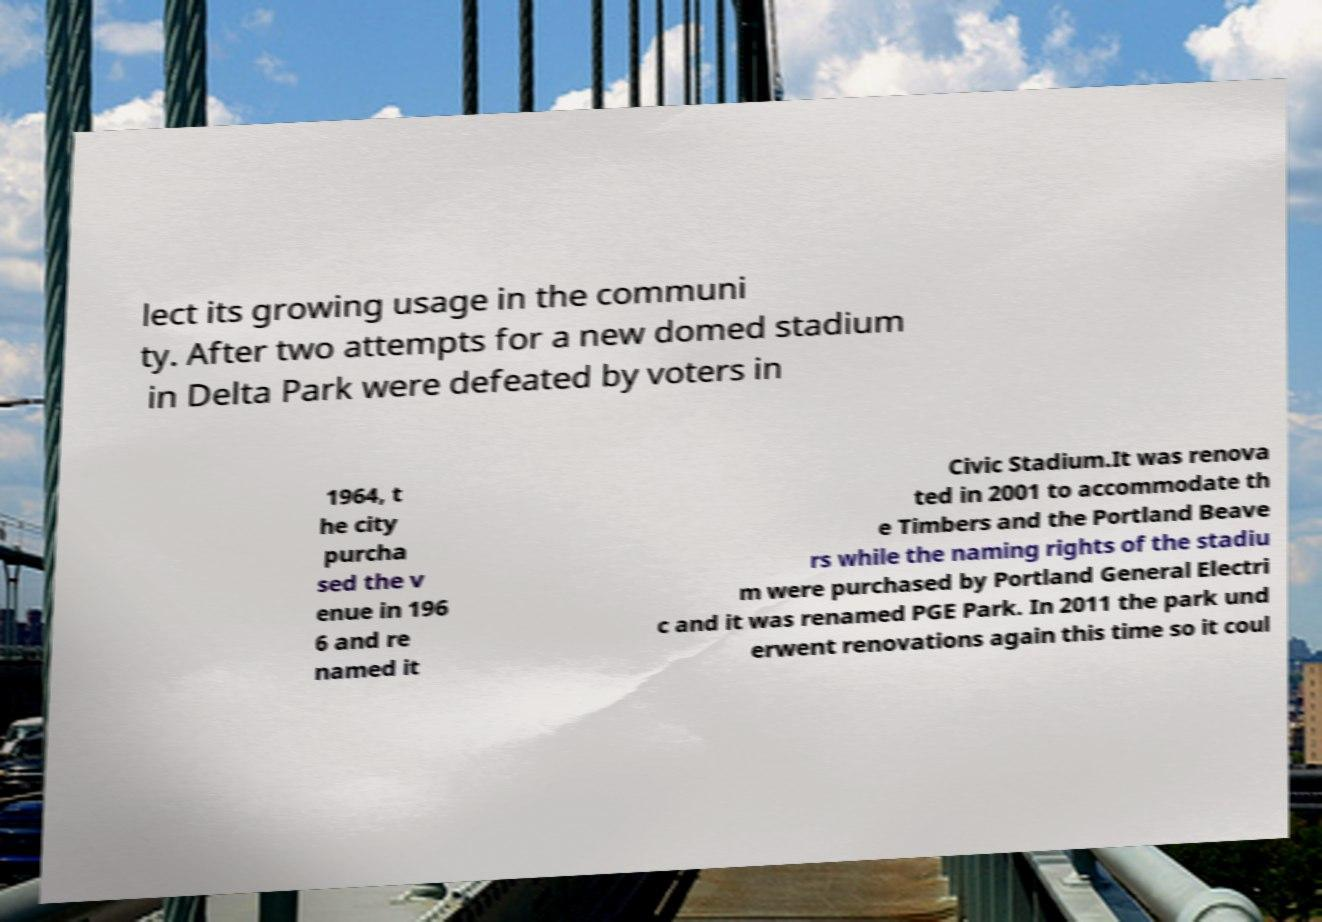What messages or text are displayed in this image? I need them in a readable, typed format. lect its growing usage in the communi ty. After two attempts for a new domed stadium in Delta Park were defeated by voters in 1964, t he city purcha sed the v enue in 196 6 and re named it Civic Stadium.It was renova ted in 2001 to accommodate th e Timbers and the Portland Beave rs while the naming rights of the stadiu m were purchased by Portland General Electri c and it was renamed PGE Park. In 2011 the park und erwent renovations again this time so it coul 